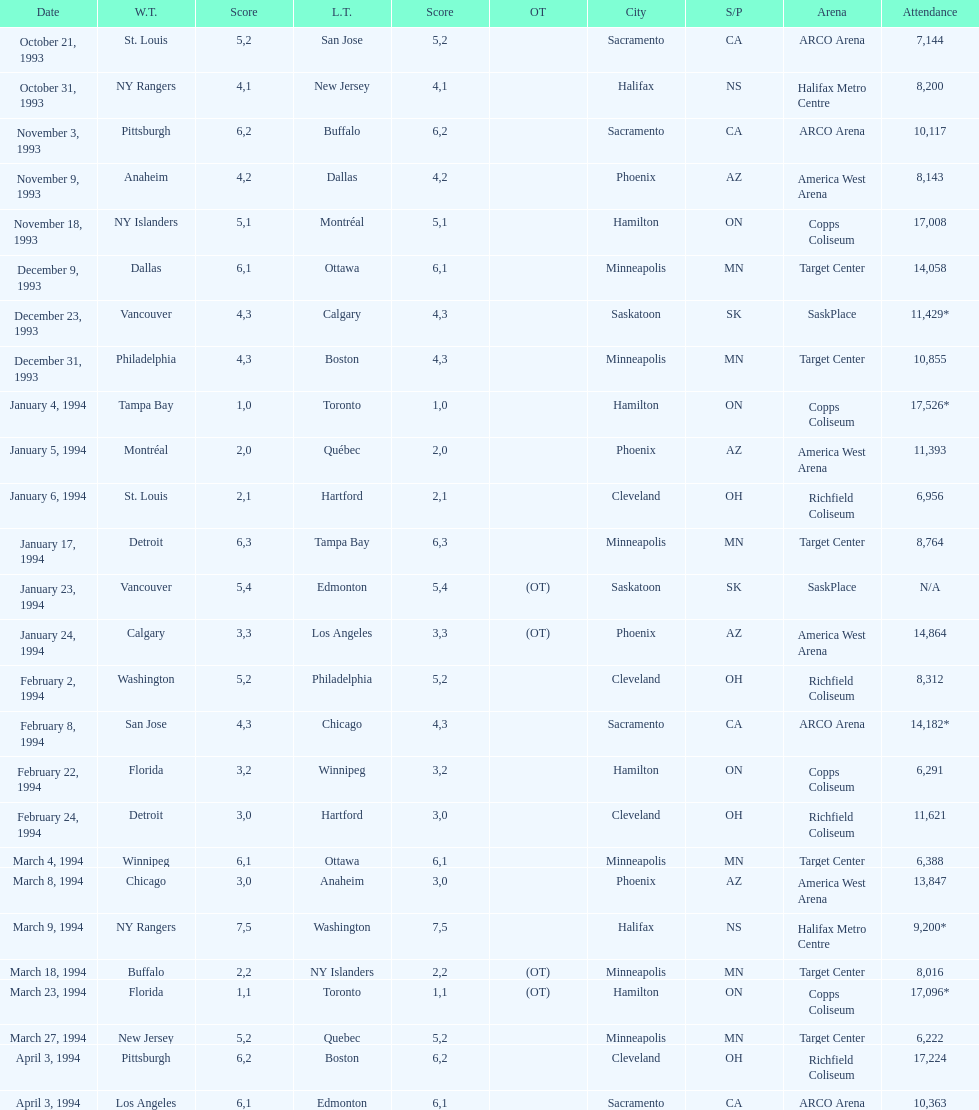The game on which date had the most attendance? January 4, 1994. 